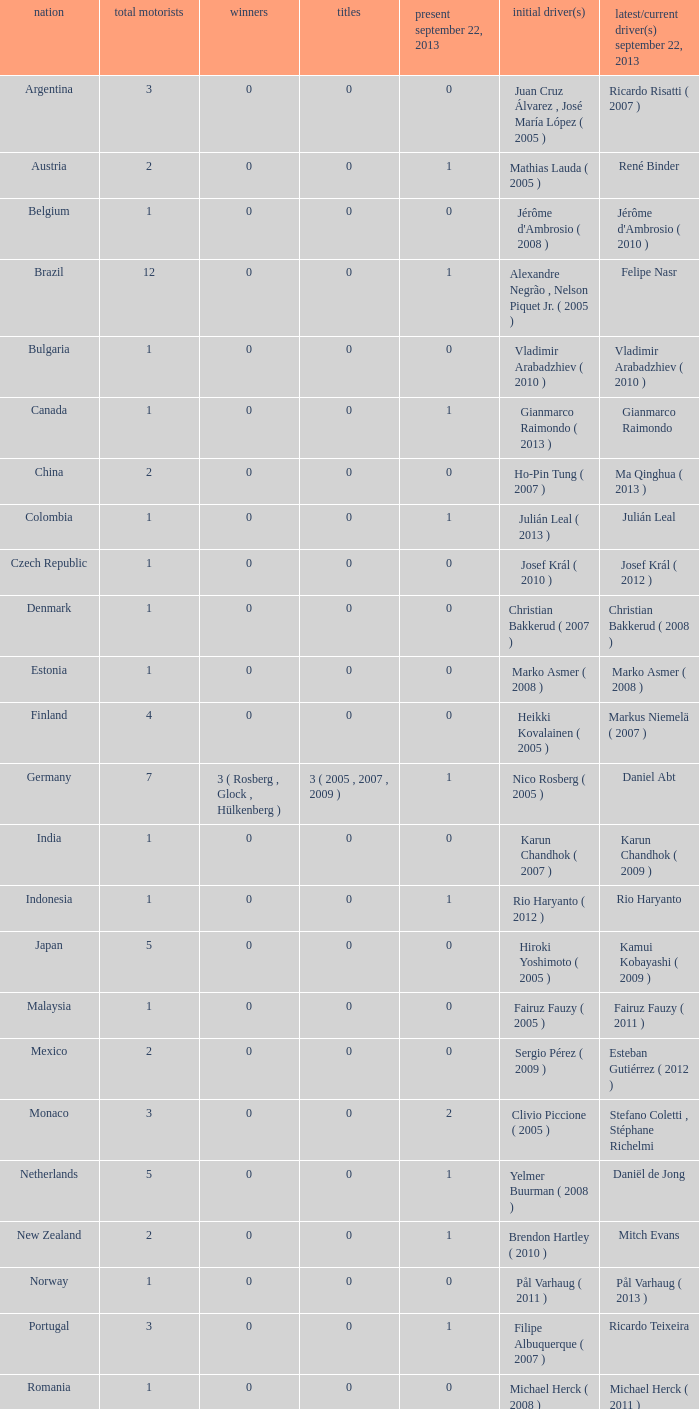How many champions were there when the last driver for September 22, 2013 was vladimir arabadzhiev ( 2010 )? 0.0. 